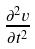<formula> <loc_0><loc_0><loc_500><loc_500>\frac { \partial ^ { 2 } v } { \partial t ^ { 2 } }</formula> 